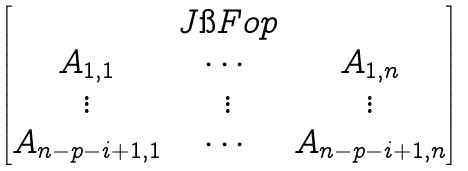<formula> <loc_0><loc_0><loc_500><loc_500>\begin{bmatrix} & J \i F o p & \\ A _ { 1 , 1 } & \cdots & A _ { 1 , n } \\ \vdots & \vdots & \vdots \\ A _ { n - p - i + 1 , 1 } & \cdots & A _ { n - p - i + 1 , n } \\ \end{bmatrix}</formula> 